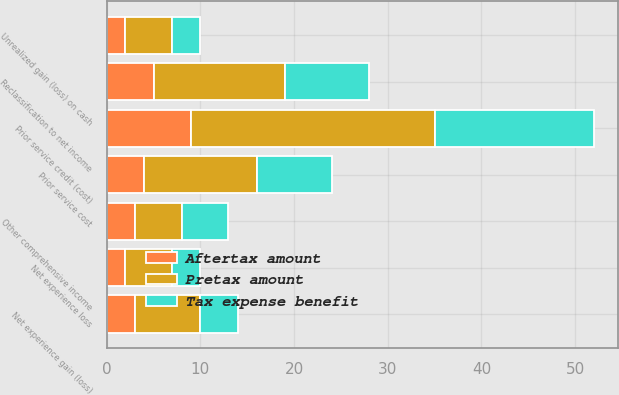Convert chart. <chart><loc_0><loc_0><loc_500><loc_500><stacked_bar_chart><ecel><fcel>Unrealized gain (loss) on cash<fcel>Reclassification to net income<fcel>Net experience gain (loss)<fcel>Prior service credit (cost)<fcel>Net experience loss<fcel>Prior service cost<fcel>Other comprehensive income<nl><fcel>Pretax amount<fcel>5<fcel>14<fcel>7<fcel>26<fcel>5<fcel>12<fcel>5<nl><fcel>Aftertax amount<fcel>2<fcel>5<fcel>3<fcel>9<fcel>2<fcel>4<fcel>3<nl><fcel>Tax expense benefit<fcel>3<fcel>9<fcel>4<fcel>17<fcel>3<fcel>8<fcel>5<nl></chart> 